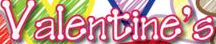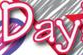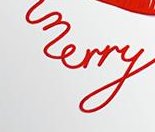What words can you see in these images in sequence, separated by a semicolon? Valentine's; Day; merry 